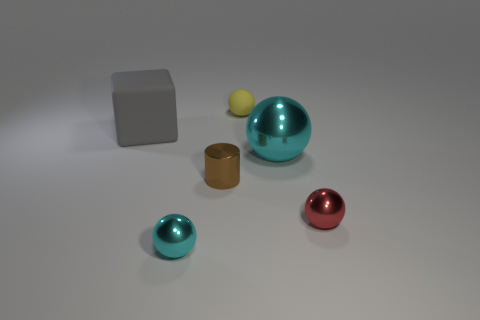Subtract all big metal balls. How many balls are left? 3 Subtract all cyan spheres. How many spheres are left? 2 Subtract 3 balls. How many balls are left? 1 Subtract all brown balls. How many yellow cubes are left? 0 Add 5 small cyan metal things. How many small cyan metal things exist? 6 Add 2 red objects. How many objects exist? 8 Subtract 0 brown blocks. How many objects are left? 6 Subtract all blocks. How many objects are left? 5 Subtract all green spheres. Subtract all green cubes. How many spheres are left? 4 Subtract all red things. Subtract all brown metallic cylinders. How many objects are left? 4 